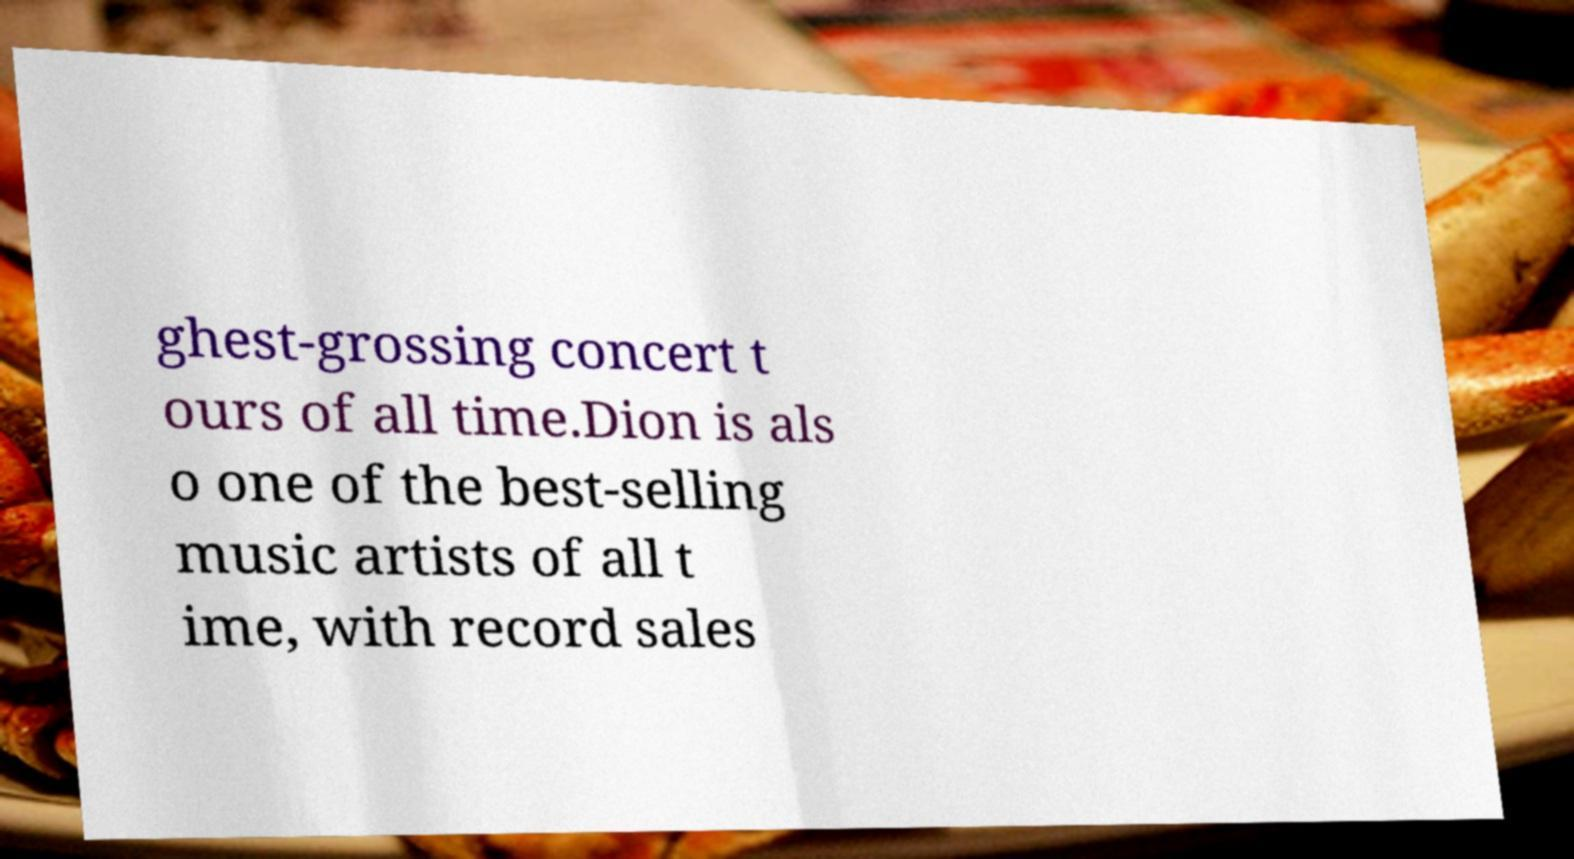Please identify and transcribe the text found in this image. ghest-grossing concert t ours of all time.Dion is als o one of the best-selling music artists of all t ime, with record sales 